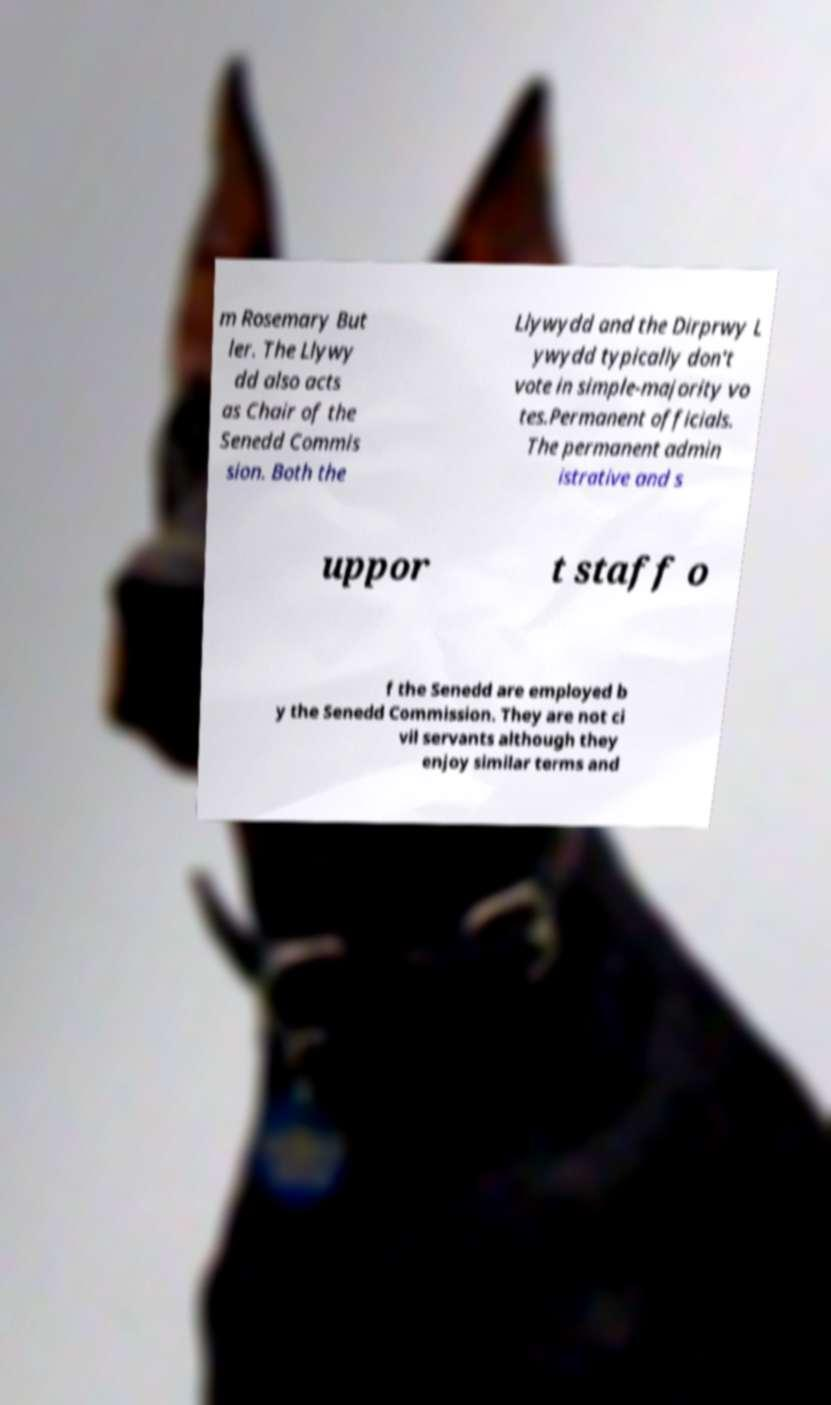Can you read and provide the text displayed in the image?This photo seems to have some interesting text. Can you extract and type it out for me? m Rosemary But ler. The Llywy dd also acts as Chair of the Senedd Commis sion. Both the Llywydd and the Dirprwy L ywydd typically don't vote in simple-majority vo tes.Permanent officials. The permanent admin istrative and s uppor t staff o f the Senedd are employed b y the Senedd Commission. They are not ci vil servants although they enjoy similar terms and 